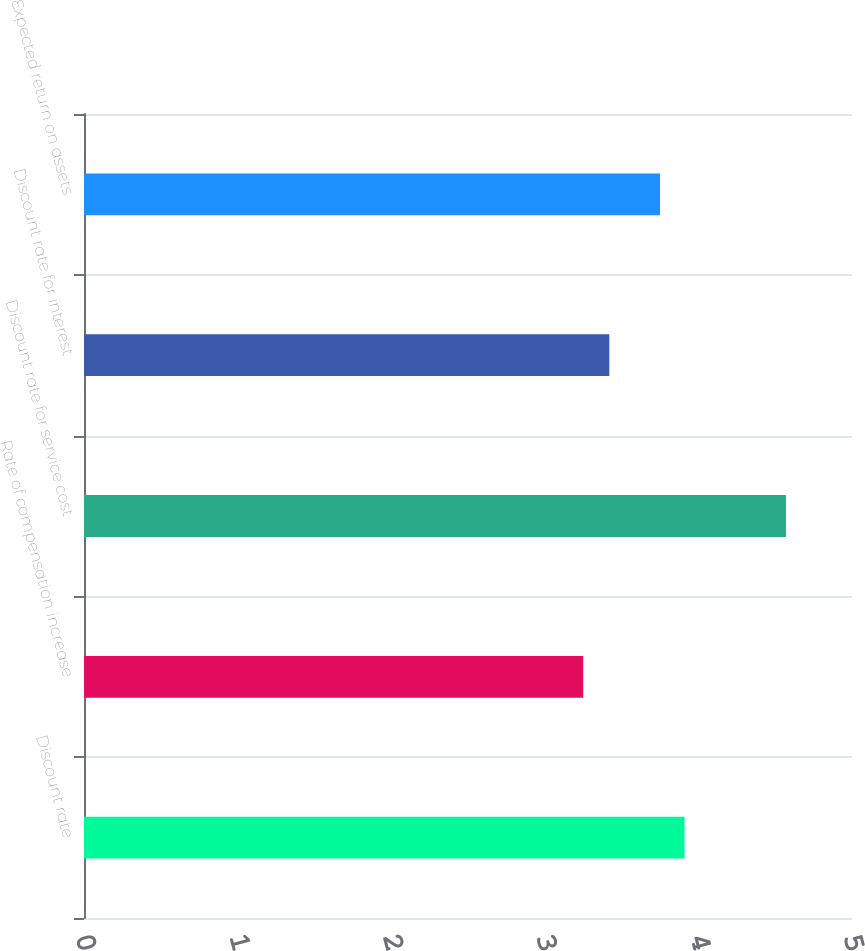Convert chart. <chart><loc_0><loc_0><loc_500><loc_500><bar_chart><fcel>Discount rate<fcel>Rate of compensation increase<fcel>Discount rate for service cost<fcel>Discount rate for interest<fcel>Expected return on assets<nl><fcel>3.91<fcel>3.25<fcel>4.57<fcel>3.42<fcel>3.75<nl></chart> 